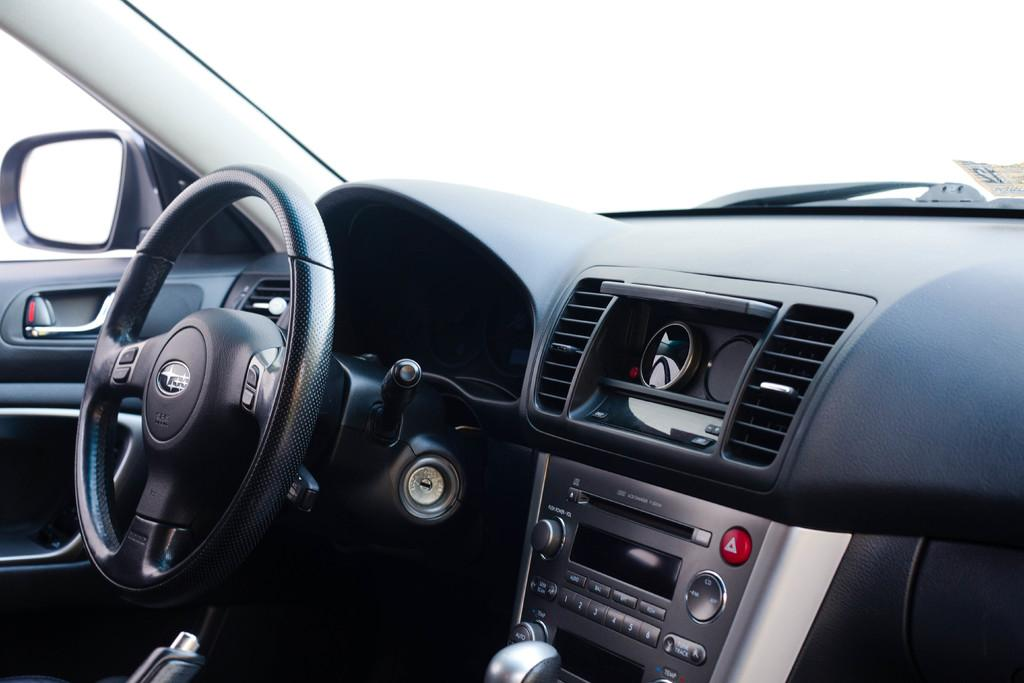What type of location is depicted in the image? The image is an inside view of a car. What is the main control device for driving the car visible in the image? The steering wheel is visible in the image. What is used to help the driver see behind them in the image? A mirror is present in the image. What other car parts can be seen in the image? Other car parts are visible in the image. How many cows are grazing in the cup in the image? There are no cows or cups present in the image; it is an inside view of a car. 